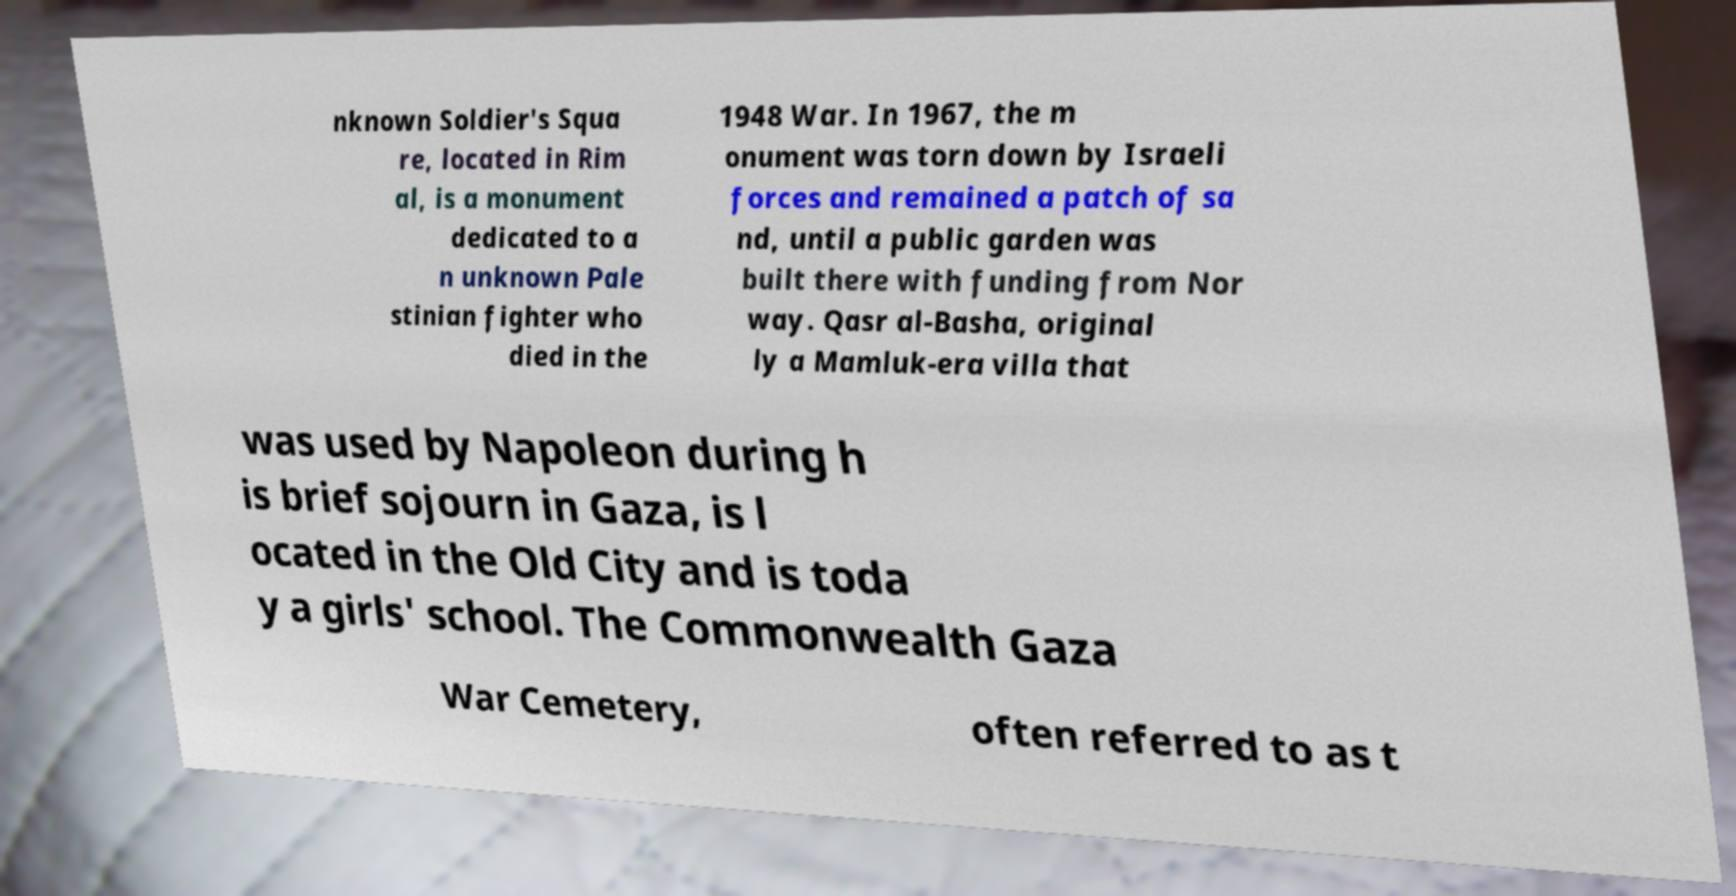I need the written content from this picture converted into text. Can you do that? nknown Soldier's Squa re, located in Rim al, is a monument dedicated to a n unknown Pale stinian fighter who died in the 1948 War. In 1967, the m onument was torn down by Israeli forces and remained a patch of sa nd, until a public garden was built there with funding from Nor way. Qasr al-Basha, original ly a Mamluk-era villa that was used by Napoleon during h is brief sojourn in Gaza, is l ocated in the Old City and is toda y a girls' school. The Commonwealth Gaza War Cemetery, often referred to as t 